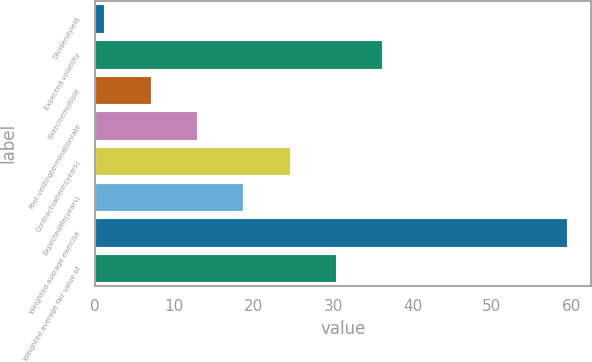Convert chart to OTSL. <chart><loc_0><loc_0><loc_500><loc_500><bar_chart><fcel>Dividendyield<fcel>Expected volatility<fcel>Exercisemultiple<fcel>Post-vestingterminationrate<fcel>Contractualterm(years)<fcel>Expectedlife(years)<fcel>Weighted average exercise<fcel>Weighted average fair value of<nl><fcel>1.21<fcel>36.19<fcel>7.04<fcel>12.87<fcel>24.53<fcel>18.7<fcel>59.48<fcel>30.36<nl></chart> 